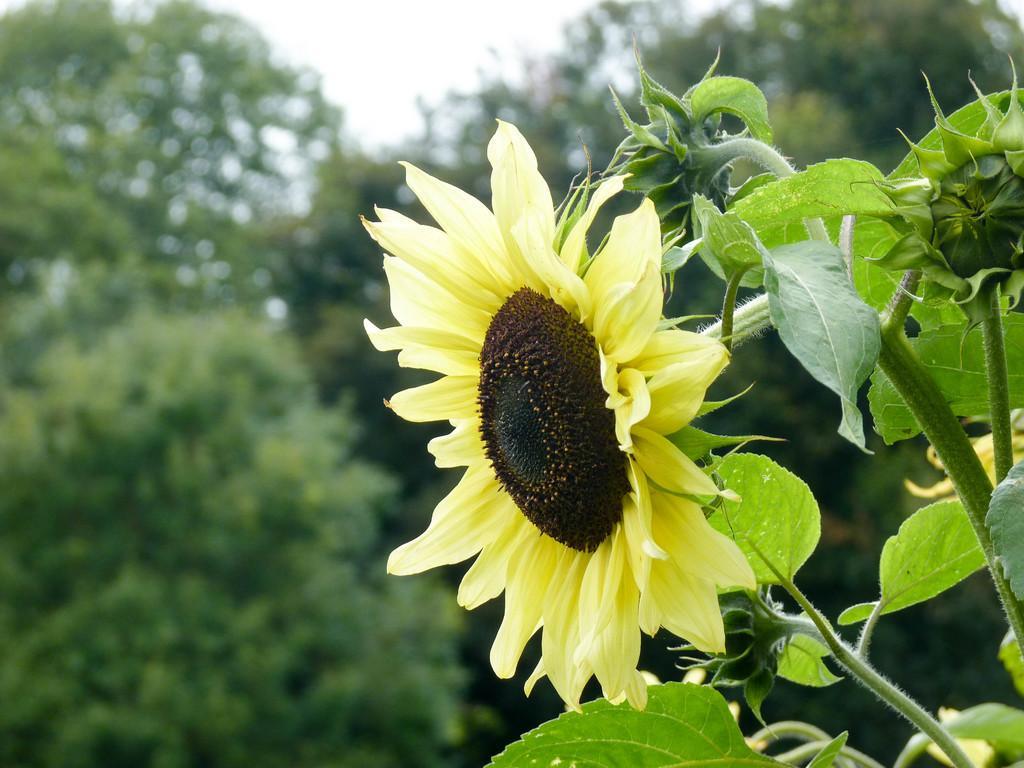Could you give a brief overview of what you see in this image? In the picture there is a sunflower to the plant and the background of the plant is blur. 